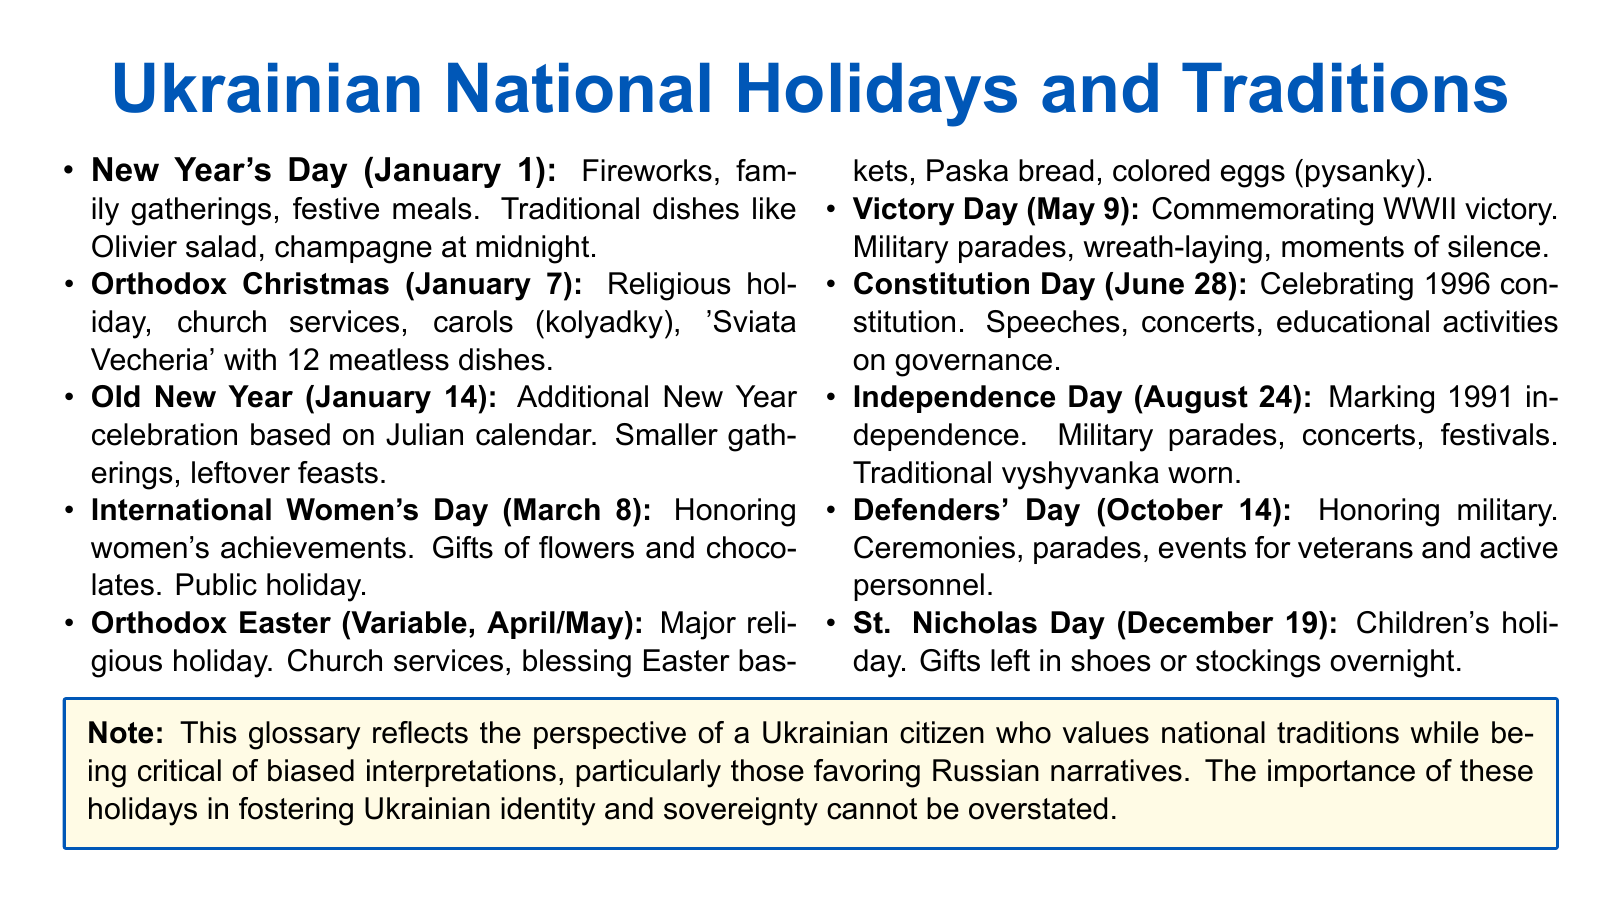What is the date of Independence Day? The date is specified in the document as August 24, marking Ukraine's independence.
Answer: August 24 What traditional dish is served during Orthodox Christmas? The document mentions 'Sviata Vecheria' with 12 meatless dishes, including Paska bread.
Answer: Paska bread What is the main focus of International Women's Day? The document states it is about honoring women's achievements, with gifts typically given.
Answer: Honoring women's achievements How many meatless dishes are served during Orthodox Christmas? The document clearly states that there are 12 meatless dishes prepared for this holiday.
Answer: 12 What event commemorates WWII victory? The document notes that Victory Day on May 9 commemorates this significant event with military parades and wreath-laying.
Answer: Victory Day What activity is common on St. Nicholas Day? The document indicates that children receive gifts left in shoes or stockings overnight, making this holiday special for them.
Answer: Gifts left in shoes Which holiday is celebrated with military parades and concerts? The document describes Independence Day as featuring military parades and concerts to celebrate Ukraine's independence.
Answer: Independence Day What type of ceremonies occur on Defenders' Day? The document mentions ceremonies and parades to honor military personnel on this day.
Answer: Ceremonies and parades 